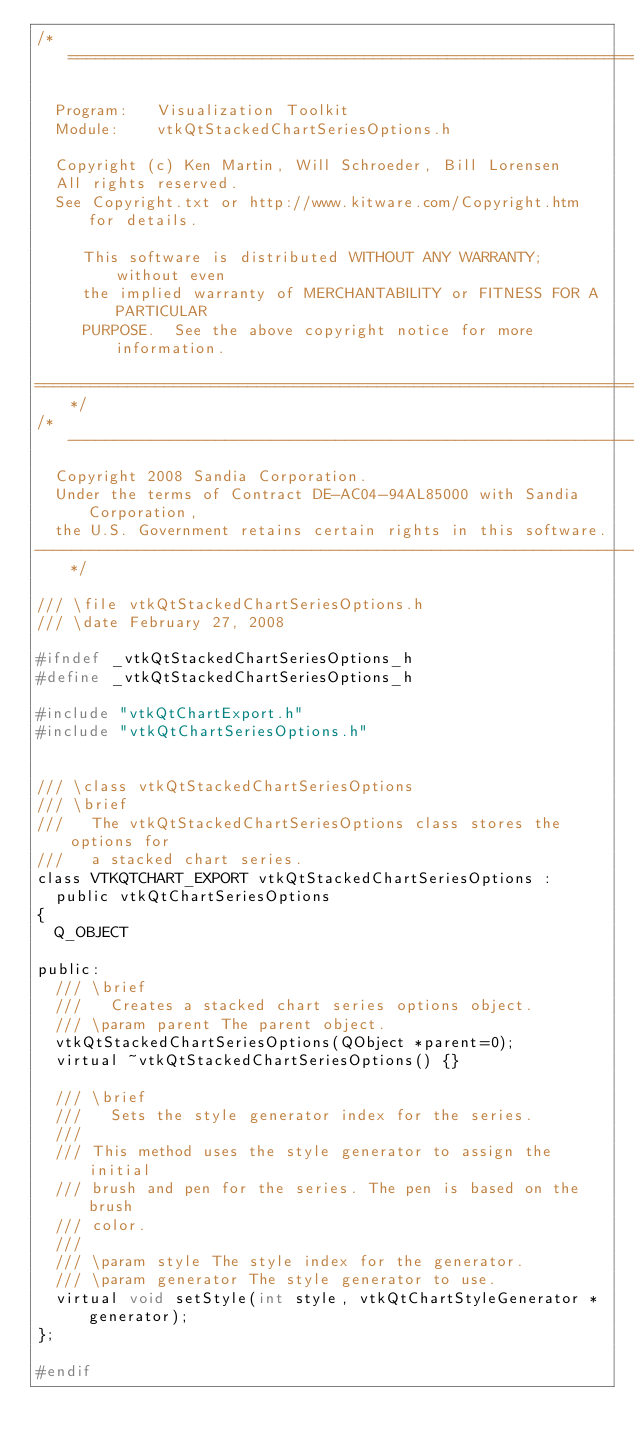Convert code to text. <code><loc_0><loc_0><loc_500><loc_500><_C_>/*=========================================================================

  Program:   Visualization Toolkit
  Module:    vtkQtStackedChartSeriesOptions.h

  Copyright (c) Ken Martin, Will Schroeder, Bill Lorensen
  All rights reserved.
  See Copyright.txt or http://www.kitware.com/Copyright.htm for details.

     This software is distributed WITHOUT ANY WARRANTY; without even
     the implied warranty of MERCHANTABILITY or FITNESS FOR A PARTICULAR
     PURPOSE.  See the above copyright notice for more information.

=========================================================================*/
/*-------------------------------------------------------------------------
  Copyright 2008 Sandia Corporation.
  Under the terms of Contract DE-AC04-94AL85000 with Sandia Corporation,
  the U.S. Government retains certain rights in this software.
-------------------------------------------------------------------------*/

/// \file vtkQtStackedChartSeriesOptions.h
/// \date February 27, 2008

#ifndef _vtkQtStackedChartSeriesOptions_h
#define _vtkQtStackedChartSeriesOptions_h

#include "vtkQtChartExport.h"
#include "vtkQtChartSeriesOptions.h"


/// \class vtkQtStackedChartSeriesOptions
/// \brief
///   The vtkQtStackedChartSeriesOptions class stores the options for
///   a stacked chart series.
class VTKQTCHART_EXPORT vtkQtStackedChartSeriesOptions :
  public vtkQtChartSeriesOptions
{
  Q_OBJECT

public:
  /// \brief
  ///   Creates a stacked chart series options object.
  /// \param parent The parent object.
  vtkQtStackedChartSeriesOptions(QObject *parent=0);
  virtual ~vtkQtStackedChartSeriesOptions() {}

  /// \brief
  ///   Sets the style generator index for the series.
  ///
  /// This method uses the style generator to assign the initial
  /// brush and pen for the series. The pen is based on the brush
  /// color.
  ///
  /// \param style The style index for the generator.
  /// \param generator The style generator to use.
  virtual void setStyle(int style, vtkQtChartStyleGenerator *generator);
};

#endif
</code> 